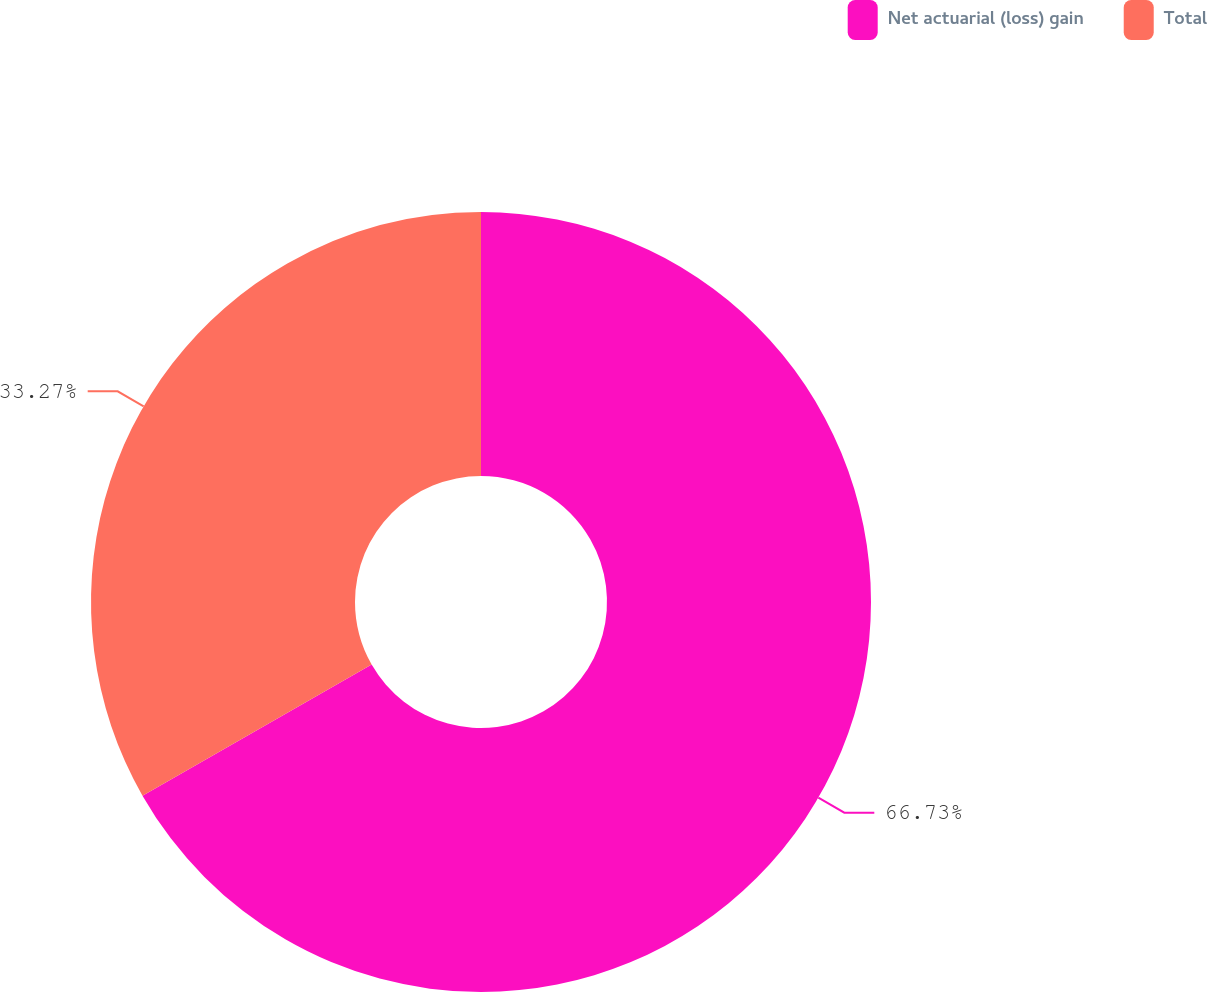<chart> <loc_0><loc_0><loc_500><loc_500><pie_chart><fcel>Net actuarial (loss) gain<fcel>Total<nl><fcel>66.73%<fcel>33.27%<nl></chart> 